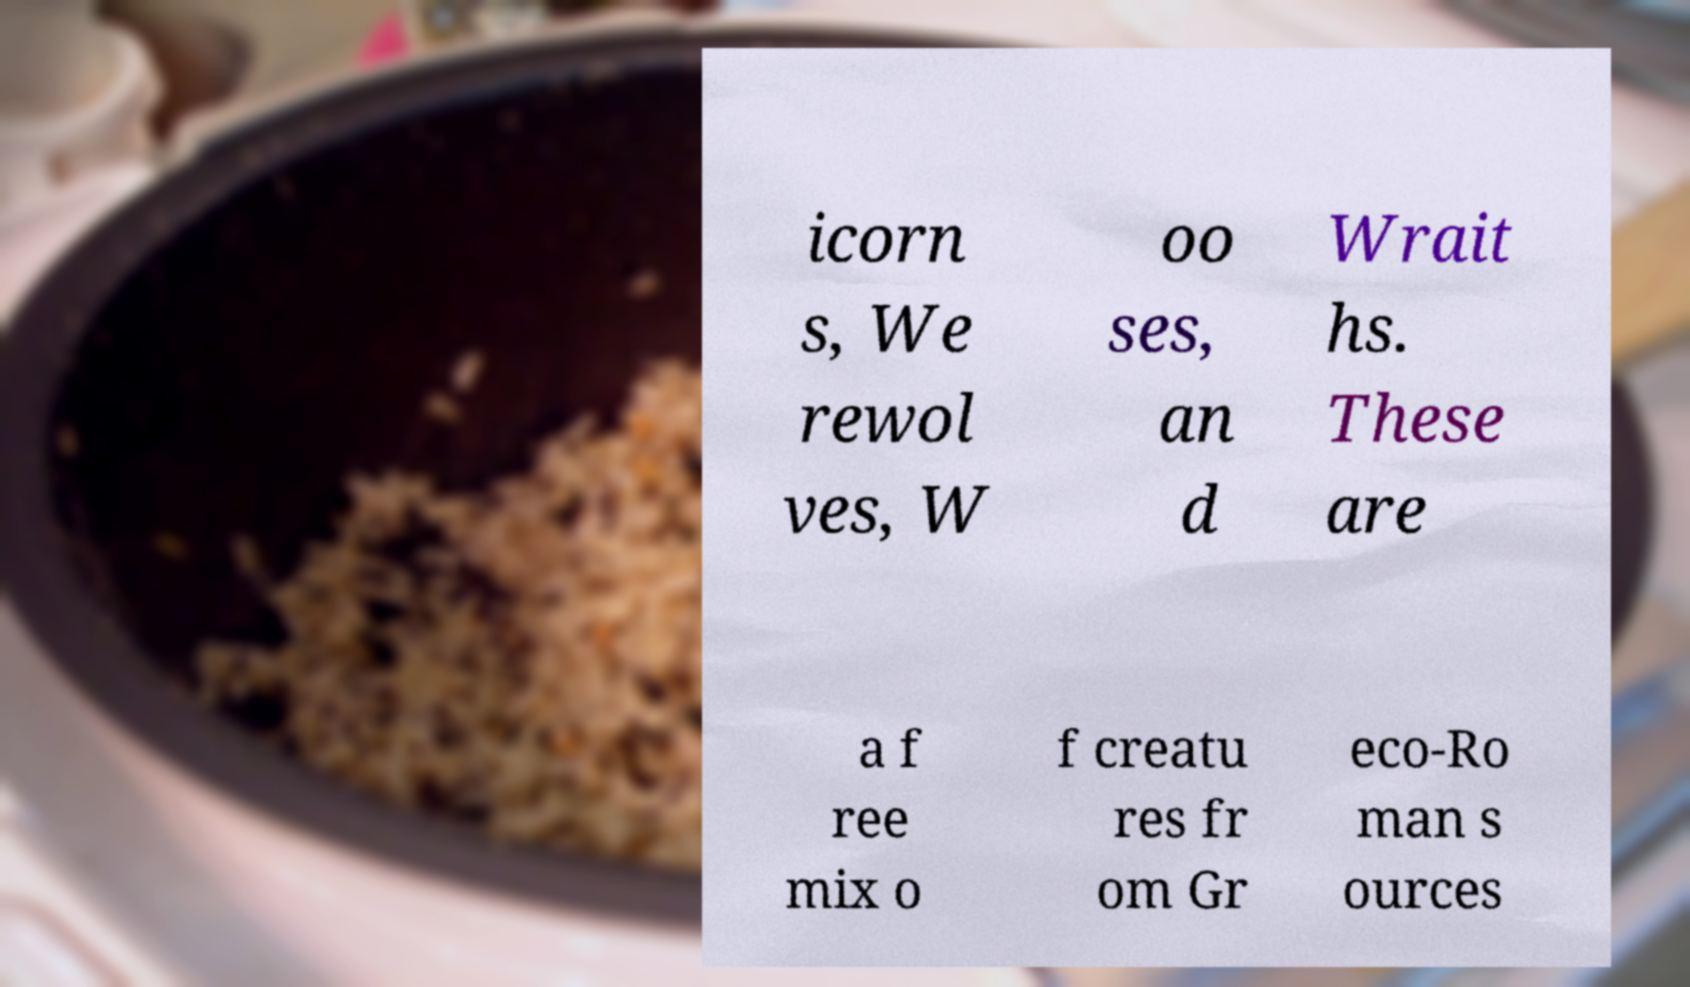Please read and relay the text visible in this image. What does it say? icorn s, We rewol ves, W oo ses, an d Wrait hs. These are a f ree mix o f creatu res fr om Gr eco-Ro man s ources 